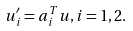<formula> <loc_0><loc_0><loc_500><loc_500>u _ { i } ^ { \prime } = { a _ { i } ^ { T } } { u } , i = 1 , 2 .</formula> 